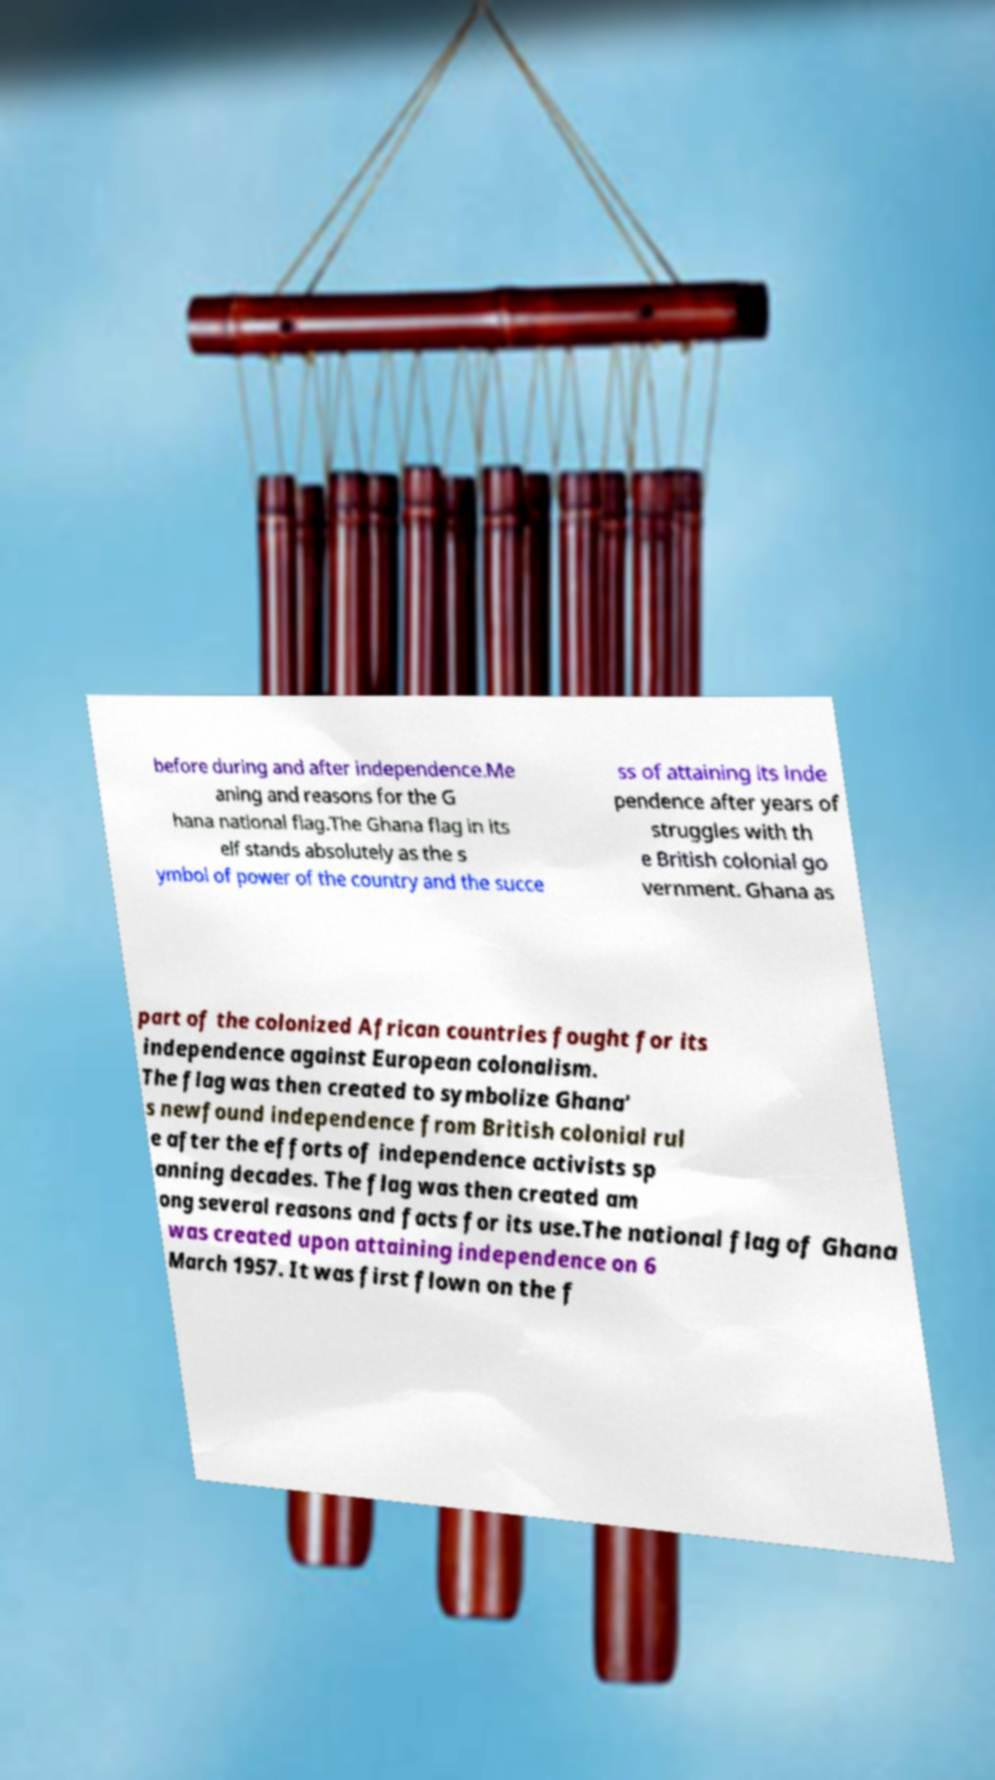There's text embedded in this image that I need extracted. Can you transcribe it verbatim? before during and after independence.Me aning and reasons for the G hana national flag.The Ghana flag in its elf stands absolutely as the s ymbol of power of the country and the succe ss of attaining its inde pendence after years of struggles with th e British colonial go vernment. Ghana as part of the colonized African countries fought for its independence against European colonalism. The flag was then created to symbolize Ghana' s newfound independence from British colonial rul e after the efforts of independence activists sp anning decades. The flag was then created am ong several reasons and facts for its use.The national flag of Ghana was created upon attaining independence on 6 March 1957. It was first flown on the f 